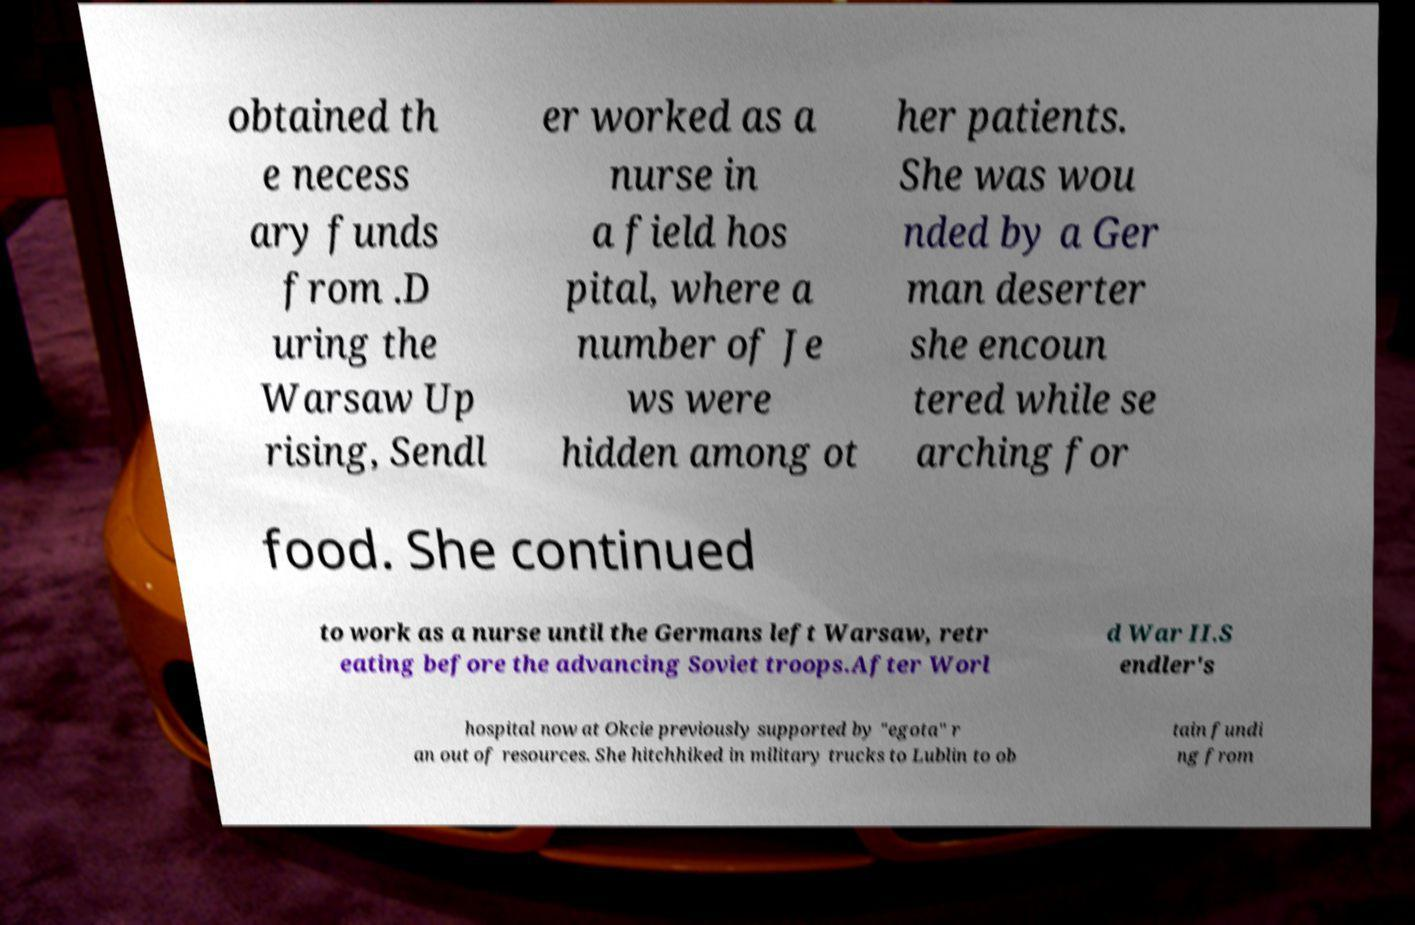Could you assist in decoding the text presented in this image and type it out clearly? obtained th e necess ary funds from .D uring the Warsaw Up rising, Sendl er worked as a nurse in a field hos pital, where a number of Je ws were hidden among ot her patients. She was wou nded by a Ger man deserter she encoun tered while se arching for food. She continued to work as a nurse until the Germans left Warsaw, retr eating before the advancing Soviet troops.After Worl d War II.S endler's hospital now at Okcie previously supported by "egota" r an out of resources. She hitchhiked in military trucks to Lublin to ob tain fundi ng from 